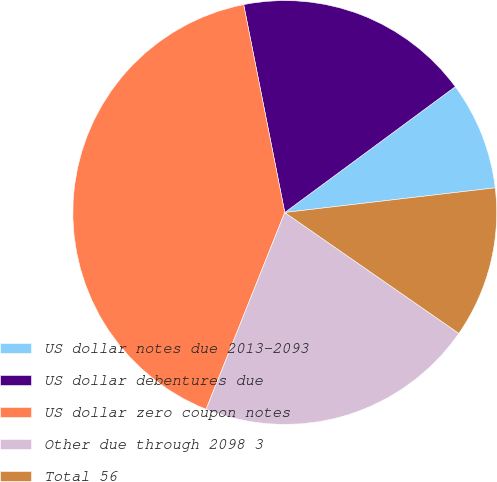<chart> <loc_0><loc_0><loc_500><loc_500><pie_chart><fcel>US dollar notes due 2013-2093<fcel>US dollar debentures due<fcel>US dollar zero coupon notes<fcel>Other due through 2098 3<fcel>Total 56<nl><fcel>8.26%<fcel>17.99%<fcel>40.84%<fcel>21.39%<fcel>11.52%<nl></chart> 